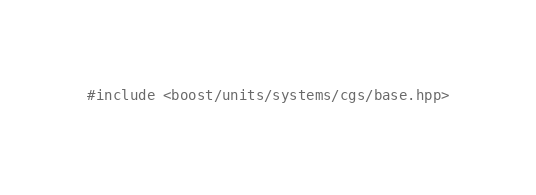<code> <loc_0><loc_0><loc_500><loc_500><_C++_>#include <boost/units/systems/cgs/base.hpp>
</code> 